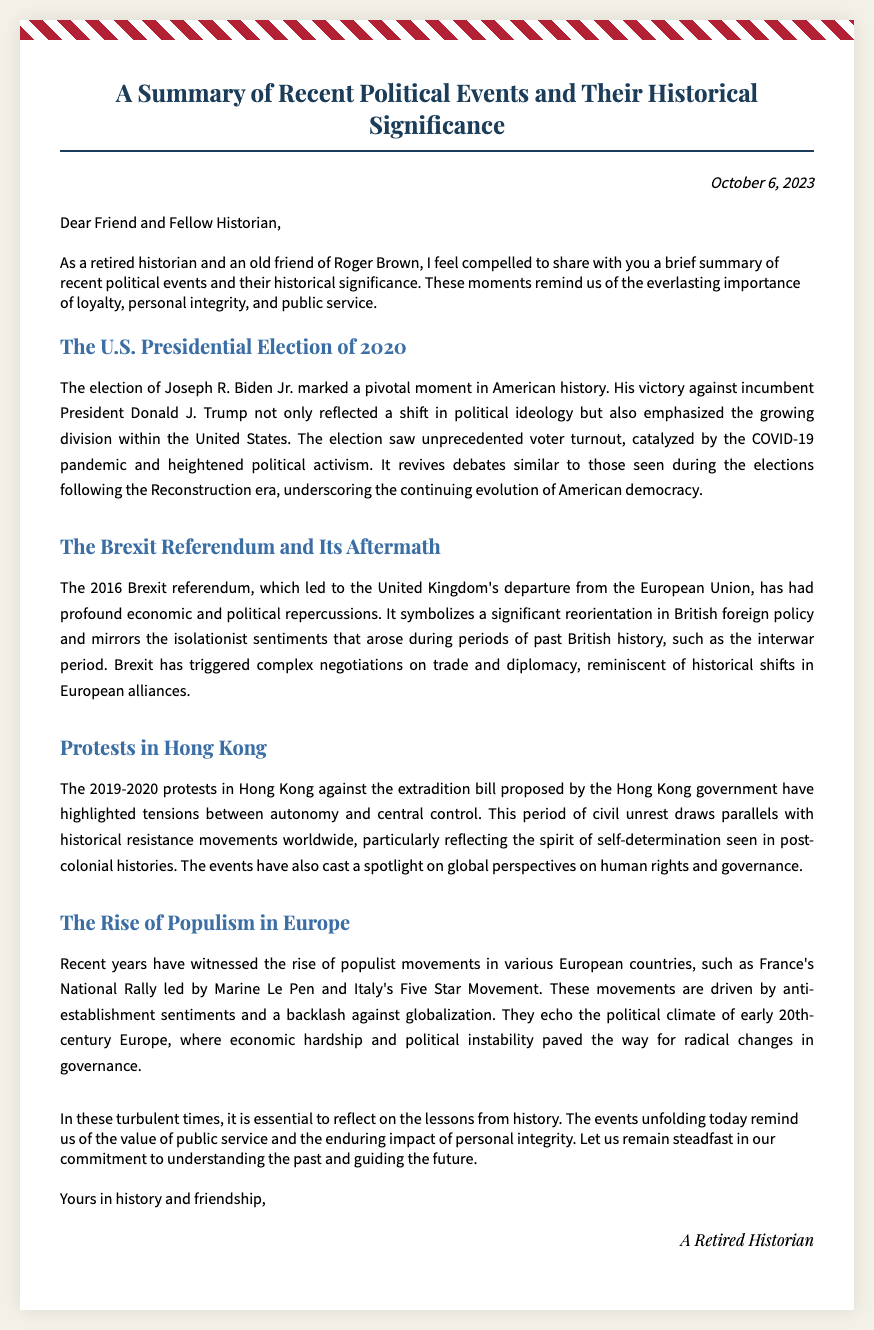What is the date of the document? The date is found in the header section of the document.
Answer: October 6, 2023 Who is the author of the document? The author is indicated at the end of the document in the signature section.
Answer: A Retired Historian What prominent political event is discussed first in the document? The first discussed event is provided in the body section headings.
Answer: The U.S. Presidential Election of 2020 What was a major outcome of the Brexit referendum? The outcome is inferred from the text discussing British foreign policy changes.
Answer: Departure from the European Union Which protest movement is highlighted in the document? The main protest movement appears in the titles of the body sections.
Answer: Protests in Hong Kong What does the author emphasize as important values during turbulent times? The values are mentioned in the conclusion of the document.
Answer: Public service and personal integrity How is the rise of populism in Europe described? The description is summarized in the section about populism with context about sentiments and governance.
Answer: Anti-establishment sentiments Which historical period does the author compare the Brexit situation to? The comparison is noted in the body section discussing Brexit.
Answer: The interwar period 